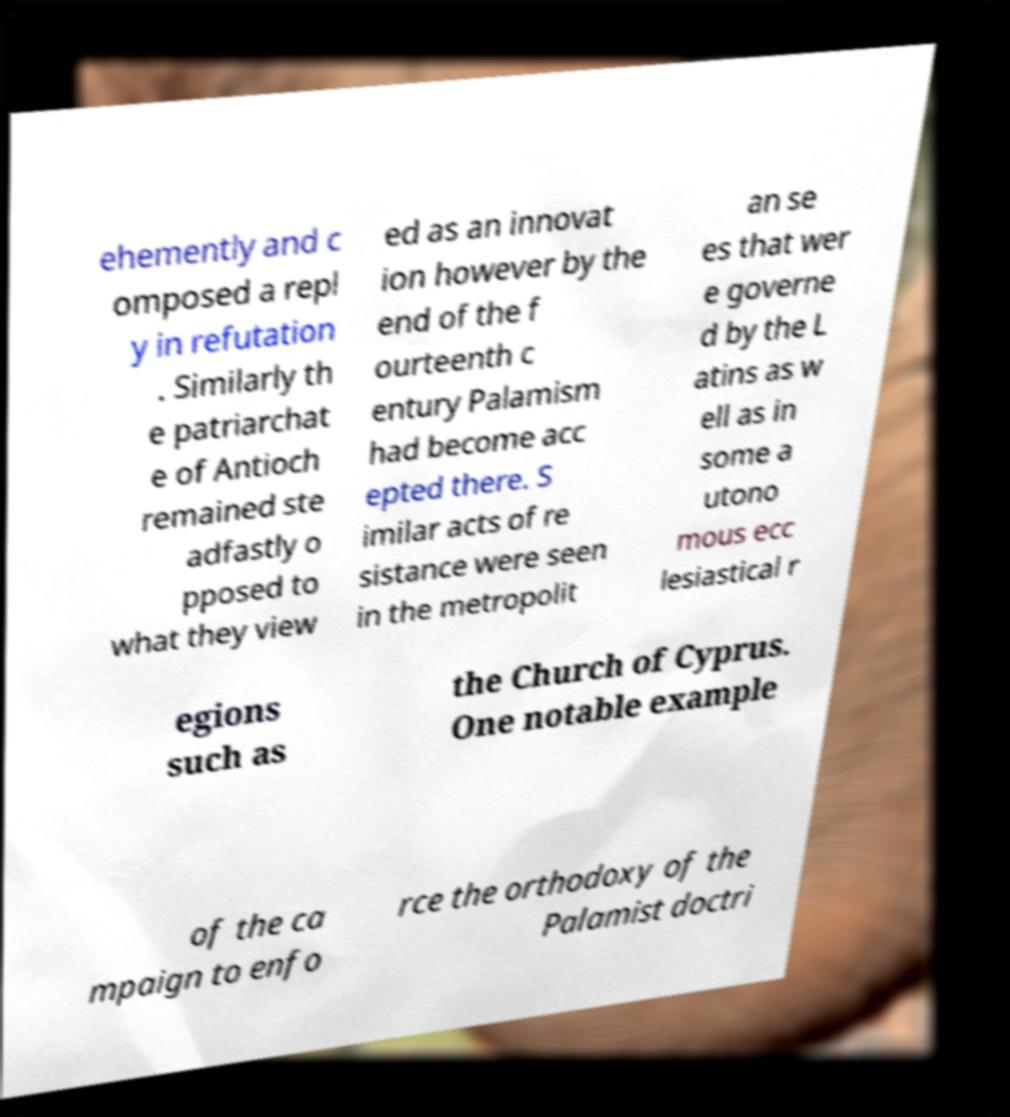Could you assist in decoding the text presented in this image and type it out clearly? ehemently and c omposed a repl y in refutation . Similarly th e patriarchat e of Antioch remained ste adfastly o pposed to what they view ed as an innovat ion however by the end of the f ourteenth c entury Palamism had become acc epted there. S imilar acts of re sistance were seen in the metropolit an se es that wer e governe d by the L atins as w ell as in some a utono mous ecc lesiastical r egions such as the Church of Cyprus. One notable example of the ca mpaign to enfo rce the orthodoxy of the Palamist doctri 